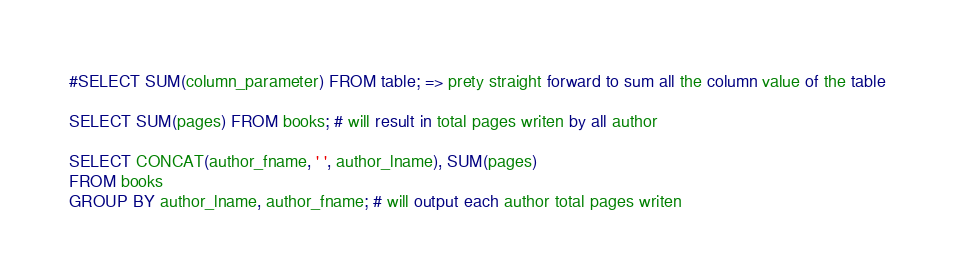<code> <loc_0><loc_0><loc_500><loc_500><_SQL_>#SELECT SUM(column_parameter) FROM table; => prety straight forward to sum all the column value of the table

SELECT SUM(pages) FROM books; # will result in total pages writen by all author

SELECT CONCAT(author_fname, ' ', author_lname), SUM(pages) 
FROM books 
GROUP BY author_lname, author_fname; # will output each author total pages writen</code> 